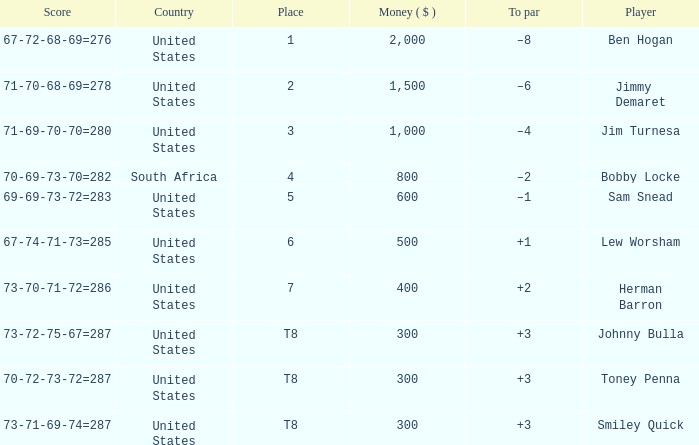What is the Place of the Player with a To par of –1? 5.0. 